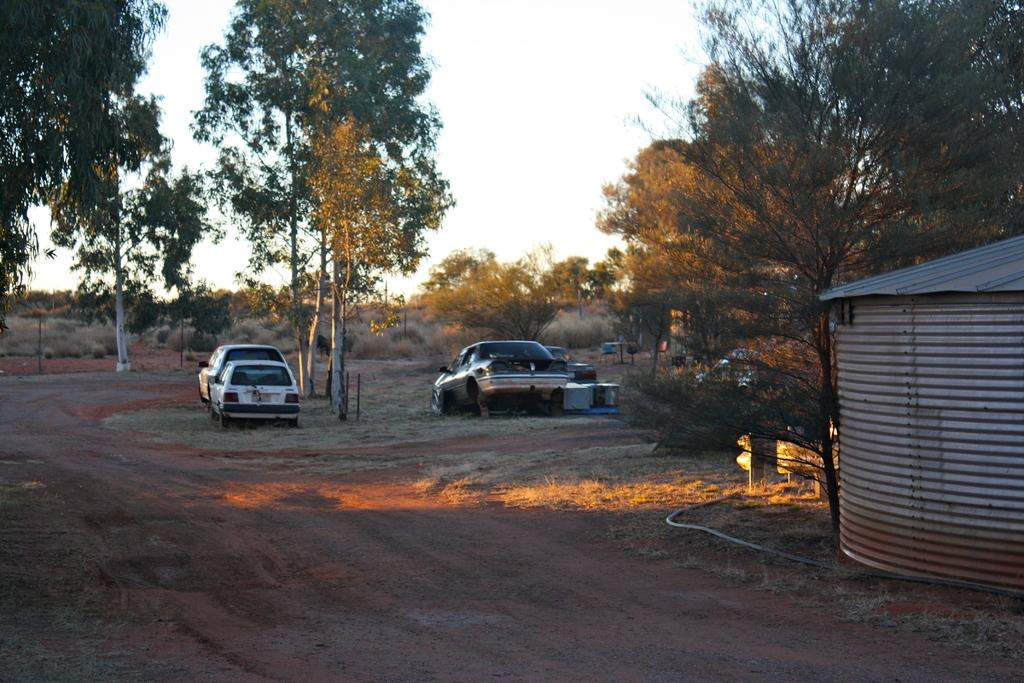What is the main subject in the image? There is a vehicle in the image. What structure can be seen in the image? There is a shed in the image. What type of vegetation is present in the image? There are trees and plants in the image. What can be seen in the background of the image? The sky is visible in the background of the image. How many girls are playing with the things in the house in the image? There are no girls or houses present in the image. 